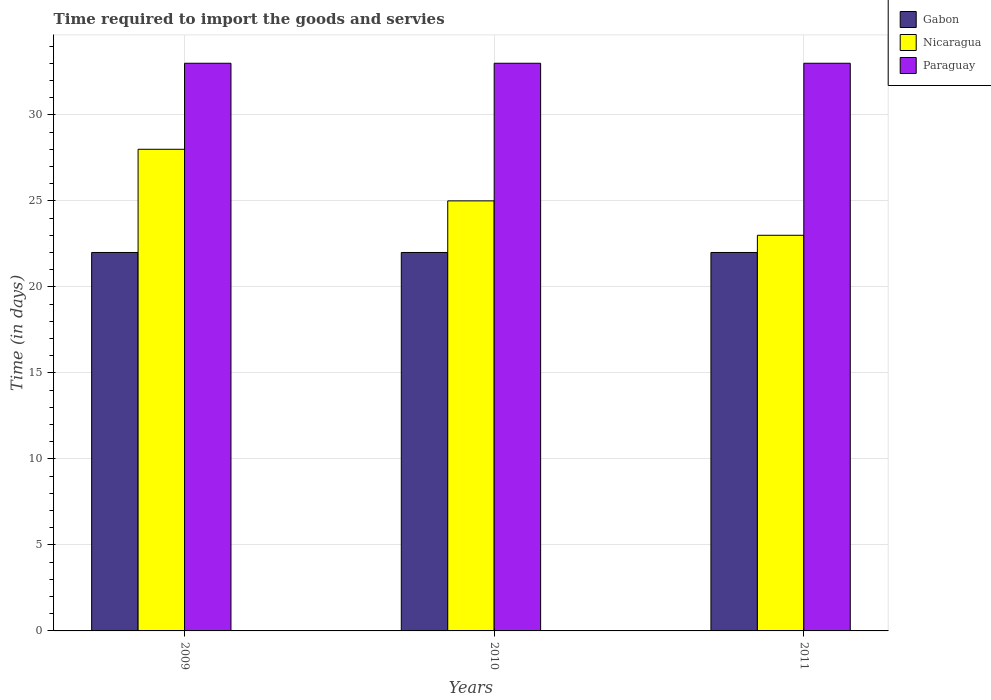How many different coloured bars are there?
Make the answer very short. 3. Are the number of bars per tick equal to the number of legend labels?
Your answer should be compact. Yes. Are the number of bars on each tick of the X-axis equal?
Your answer should be compact. Yes. How many bars are there on the 2nd tick from the right?
Make the answer very short. 3. In how many cases, is the number of bars for a given year not equal to the number of legend labels?
Offer a very short reply. 0. What is the number of days required to import the goods and services in Nicaragua in 2010?
Provide a short and direct response. 25. Across all years, what is the maximum number of days required to import the goods and services in Gabon?
Your answer should be compact. 22. Across all years, what is the minimum number of days required to import the goods and services in Gabon?
Your answer should be very brief. 22. In which year was the number of days required to import the goods and services in Paraguay maximum?
Ensure brevity in your answer.  2009. What is the total number of days required to import the goods and services in Nicaragua in the graph?
Give a very brief answer. 76. What is the difference between the number of days required to import the goods and services in Gabon in 2009 and that in 2011?
Keep it short and to the point. 0. What is the difference between the number of days required to import the goods and services in Gabon in 2011 and the number of days required to import the goods and services in Paraguay in 2009?
Offer a very short reply. -11. What is the average number of days required to import the goods and services in Gabon per year?
Your answer should be compact. 22. In the year 2010, what is the difference between the number of days required to import the goods and services in Gabon and number of days required to import the goods and services in Paraguay?
Provide a short and direct response. -11. In how many years, is the number of days required to import the goods and services in Paraguay greater than 4 days?
Ensure brevity in your answer.  3. What is the ratio of the number of days required to import the goods and services in Nicaragua in 2009 to that in 2011?
Ensure brevity in your answer.  1.22. What is the difference between the highest and the second highest number of days required to import the goods and services in Gabon?
Make the answer very short. 0. What is the difference between the highest and the lowest number of days required to import the goods and services in Nicaragua?
Keep it short and to the point. 5. In how many years, is the number of days required to import the goods and services in Gabon greater than the average number of days required to import the goods and services in Gabon taken over all years?
Provide a short and direct response. 0. Is the sum of the number of days required to import the goods and services in Paraguay in 2010 and 2011 greater than the maximum number of days required to import the goods and services in Nicaragua across all years?
Your answer should be very brief. Yes. What does the 1st bar from the left in 2009 represents?
Offer a very short reply. Gabon. What does the 1st bar from the right in 2010 represents?
Provide a short and direct response. Paraguay. How many bars are there?
Provide a short and direct response. 9. Are all the bars in the graph horizontal?
Make the answer very short. No. How many years are there in the graph?
Make the answer very short. 3. What is the difference between two consecutive major ticks on the Y-axis?
Provide a succinct answer. 5. Does the graph contain any zero values?
Ensure brevity in your answer.  No. Where does the legend appear in the graph?
Provide a succinct answer. Top right. How many legend labels are there?
Your answer should be compact. 3. What is the title of the graph?
Offer a very short reply. Time required to import the goods and servies. What is the label or title of the Y-axis?
Give a very brief answer. Time (in days). What is the Time (in days) of Gabon in 2011?
Your answer should be very brief. 22. Across all years, what is the maximum Time (in days) of Gabon?
Provide a short and direct response. 22. What is the total Time (in days) of Gabon in the graph?
Give a very brief answer. 66. What is the total Time (in days) of Nicaragua in the graph?
Make the answer very short. 76. What is the difference between the Time (in days) of Gabon in 2009 and that in 2010?
Provide a short and direct response. 0. What is the difference between the Time (in days) in Nicaragua in 2009 and that in 2010?
Ensure brevity in your answer.  3. What is the difference between the Time (in days) in Nicaragua in 2009 and that in 2011?
Give a very brief answer. 5. What is the difference between the Time (in days) of Nicaragua in 2010 and that in 2011?
Ensure brevity in your answer.  2. What is the difference between the Time (in days) of Paraguay in 2010 and that in 2011?
Your response must be concise. 0. What is the difference between the Time (in days) in Gabon in 2009 and the Time (in days) in Paraguay in 2010?
Make the answer very short. -11. What is the difference between the Time (in days) of Nicaragua in 2009 and the Time (in days) of Paraguay in 2010?
Offer a terse response. -5. What is the difference between the Time (in days) in Nicaragua in 2009 and the Time (in days) in Paraguay in 2011?
Provide a short and direct response. -5. What is the difference between the Time (in days) of Gabon in 2010 and the Time (in days) of Nicaragua in 2011?
Provide a succinct answer. -1. What is the difference between the Time (in days) of Gabon in 2010 and the Time (in days) of Paraguay in 2011?
Ensure brevity in your answer.  -11. What is the difference between the Time (in days) of Nicaragua in 2010 and the Time (in days) of Paraguay in 2011?
Provide a short and direct response. -8. What is the average Time (in days) of Gabon per year?
Your answer should be compact. 22. What is the average Time (in days) of Nicaragua per year?
Offer a very short reply. 25.33. What is the average Time (in days) in Paraguay per year?
Give a very brief answer. 33. In the year 2009, what is the difference between the Time (in days) in Gabon and Time (in days) in Paraguay?
Keep it short and to the point. -11. In the year 2011, what is the difference between the Time (in days) in Gabon and Time (in days) in Paraguay?
Ensure brevity in your answer.  -11. In the year 2011, what is the difference between the Time (in days) of Nicaragua and Time (in days) of Paraguay?
Provide a succinct answer. -10. What is the ratio of the Time (in days) in Nicaragua in 2009 to that in 2010?
Your answer should be compact. 1.12. What is the ratio of the Time (in days) of Gabon in 2009 to that in 2011?
Ensure brevity in your answer.  1. What is the ratio of the Time (in days) of Nicaragua in 2009 to that in 2011?
Offer a terse response. 1.22. What is the ratio of the Time (in days) in Paraguay in 2009 to that in 2011?
Your answer should be compact. 1. What is the ratio of the Time (in days) in Gabon in 2010 to that in 2011?
Provide a succinct answer. 1. What is the ratio of the Time (in days) of Nicaragua in 2010 to that in 2011?
Keep it short and to the point. 1.09. What is the difference between the highest and the second highest Time (in days) in Nicaragua?
Your answer should be compact. 3. What is the difference between the highest and the lowest Time (in days) in Gabon?
Give a very brief answer. 0. What is the difference between the highest and the lowest Time (in days) in Nicaragua?
Your response must be concise. 5. 